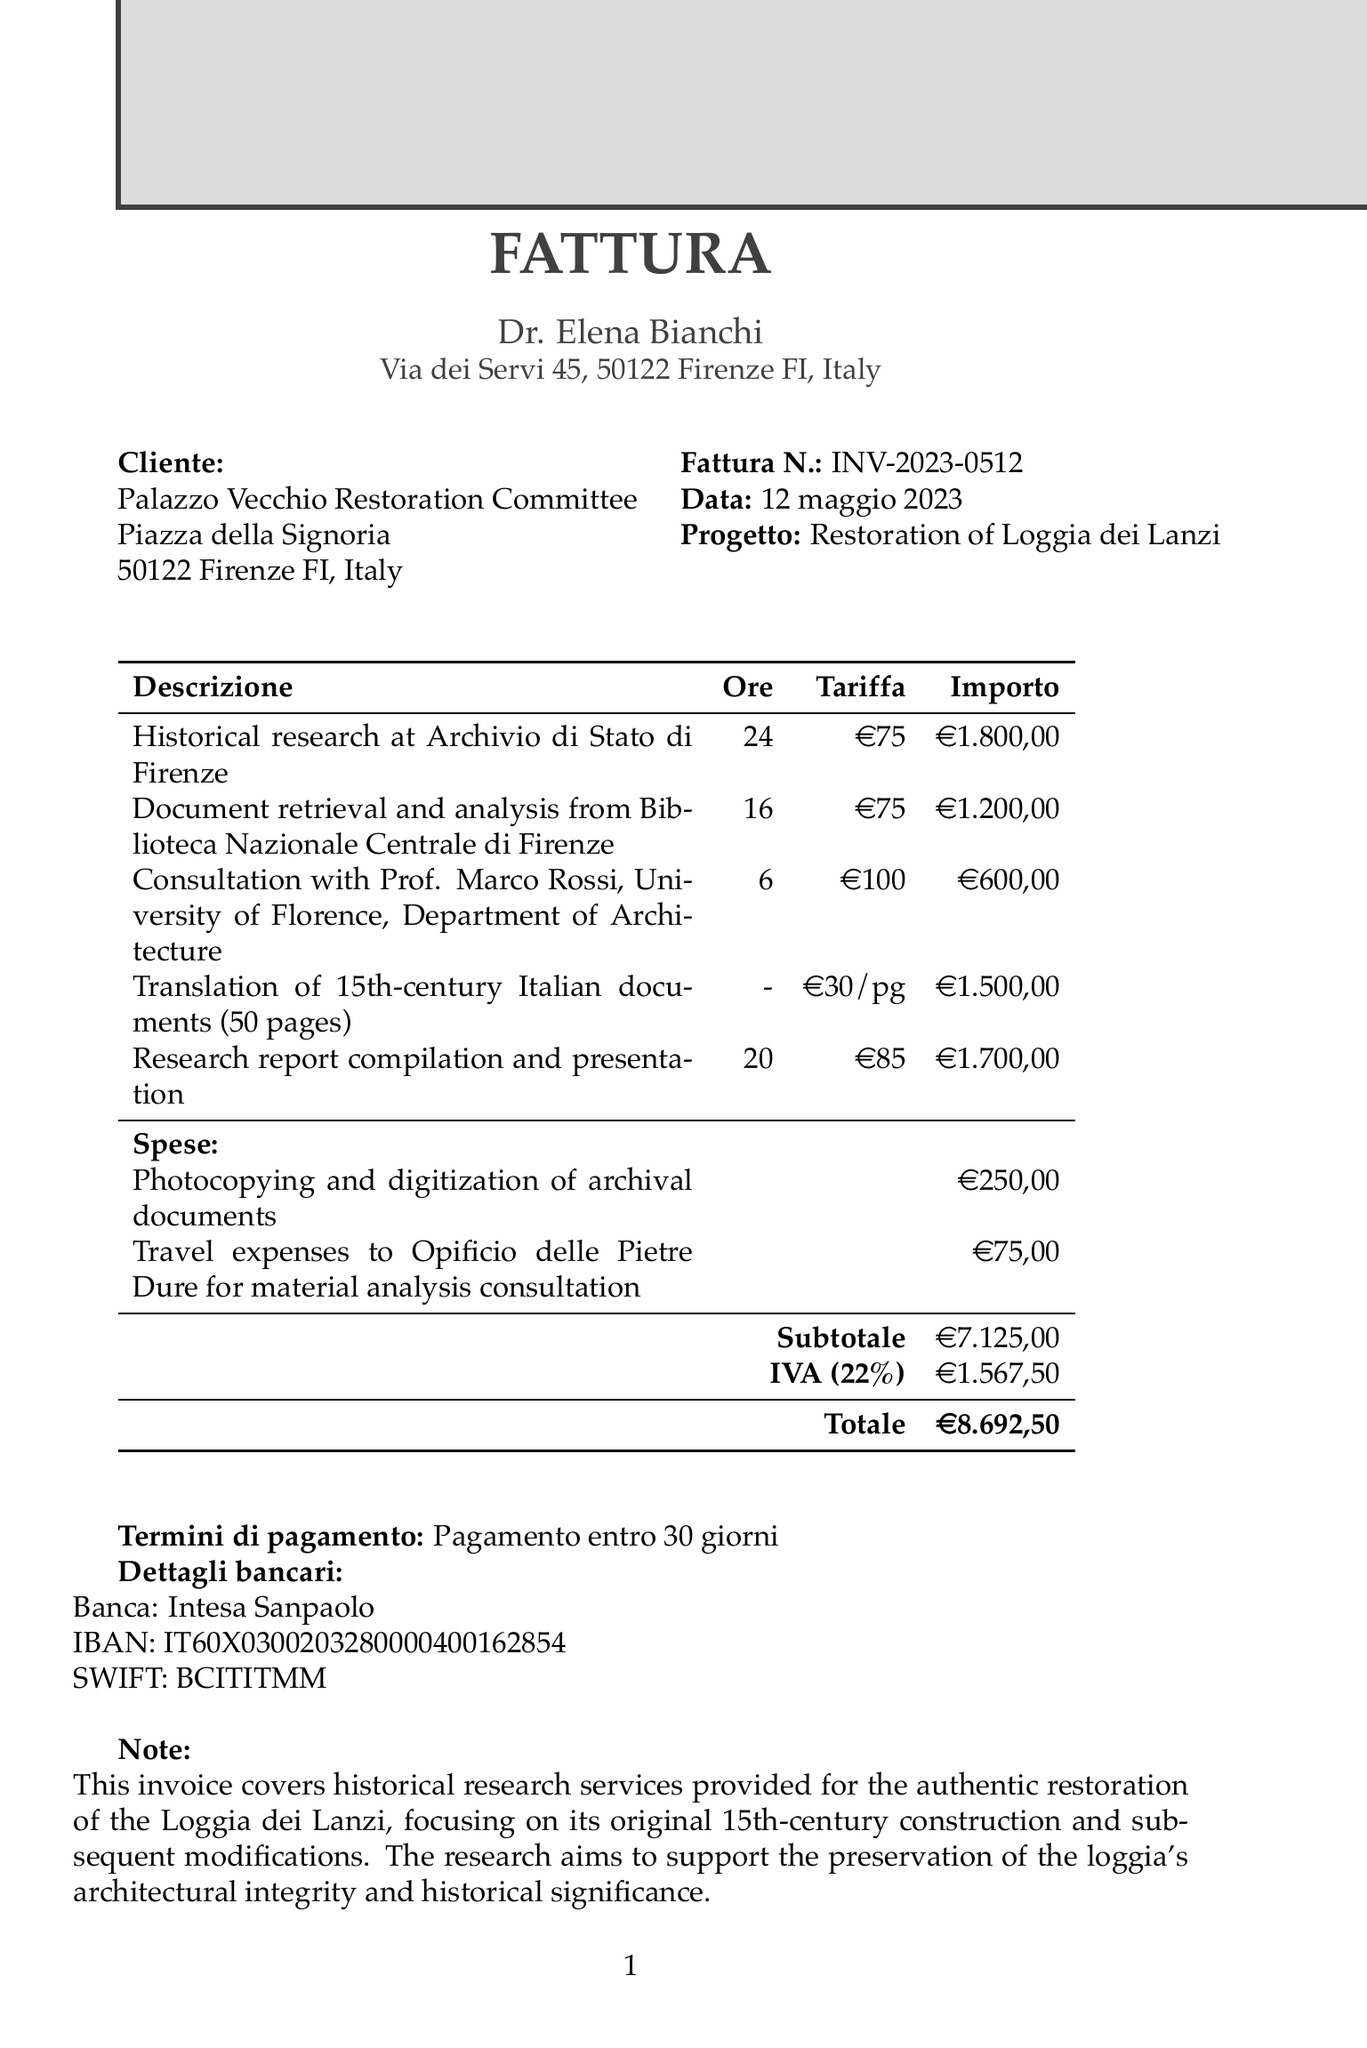What is the invoice number? The invoice number is indicated at the top of the document as a unique identifier for this transaction.
Answer: INV-2023-0512 Who is the architect? The architect's name is listed at the beginning of the document as the service provider.
Answer: Dr. Elena Bianchi What is the total amount due? The total amount is calculated after including taxes and expenses in the invoice.
Answer: €8.692,50 How many hours were spent on historical research? The document specifies the number of hours worked on each service, including historical research.
Answer: 24 What is the tax rate applied on this invoice? The tax rate is mentioned in the invoice to calculate the applicable VAT.
Answer: 22% What service is associated with a charge of €1.500,00? The invoice lists various services provided, specifying the amount charged for each service.
Answer: Translation of 15th-century Italian documents What are the payment terms stated in the invoice? The payment terms indicate the duration within which the payment should be made after receiving the invoice.
Answer: Due within 30 days What is the subtotal before tax? The subtotal is the sum of all service charges and expenses before adding any taxes.
Answer: €7.125,00 Where is the client located? The client's address is provided in the invoice for identification and contact purposes.
Answer: Piazza della Signoria, 50122 Firenze FI, Italy 